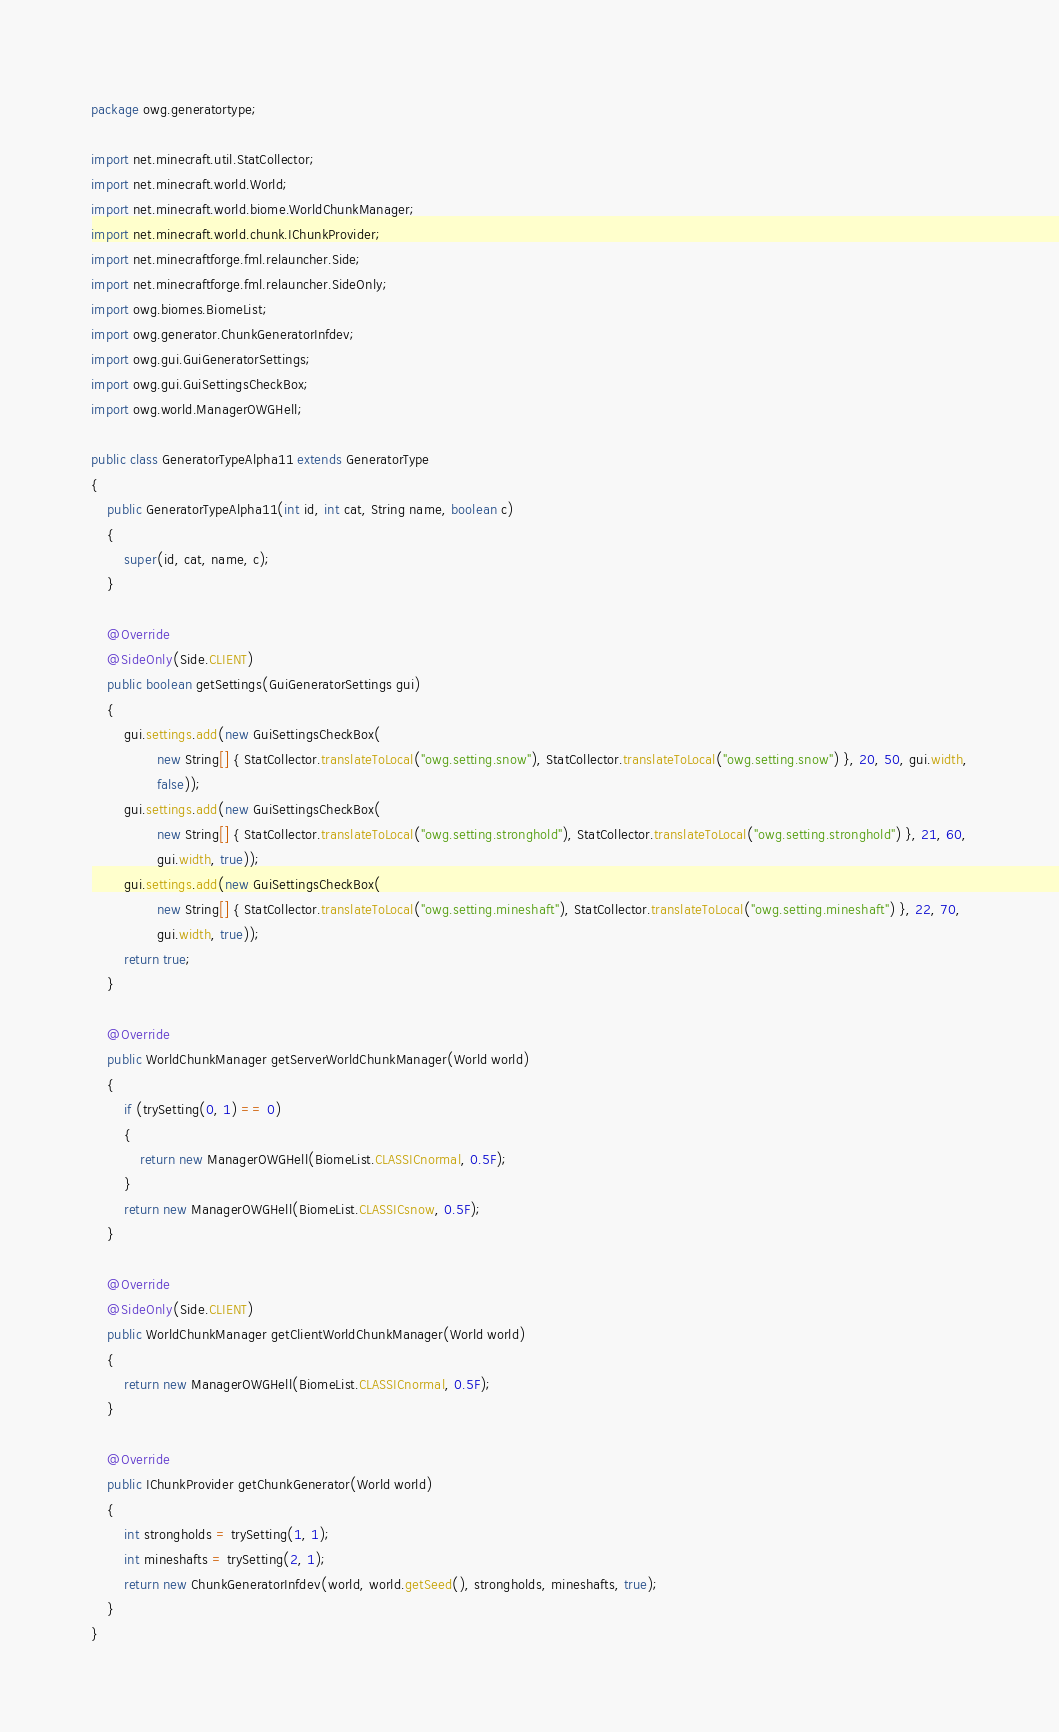Convert code to text. <code><loc_0><loc_0><loc_500><loc_500><_Java_>package owg.generatortype;

import net.minecraft.util.StatCollector;
import net.minecraft.world.World;
import net.minecraft.world.biome.WorldChunkManager;
import net.minecraft.world.chunk.IChunkProvider;
import net.minecraftforge.fml.relauncher.Side;
import net.minecraftforge.fml.relauncher.SideOnly;
import owg.biomes.BiomeList;
import owg.generator.ChunkGeneratorInfdev;
import owg.gui.GuiGeneratorSettings;
import owg.gui.GuiSettingsCheckBox;
import owg.world.ManagerOWGHell;

public class GeneratorTypeAlpha11 extends GeneratorType
{
    public GeneratorTypeAlpha11(int id, int cat, String name, boolean c)
    {
        super(id, cat, name, c);
    }

    @Override
    @SideOnly(Side.CLIENT)
    public boolean getSettings(GuiGeneratorSettings gui)
    {
        gui.settings.add(new GuiSettingsCheckBox(
                new String[] { StatCollector.translateToLocal("owg.setting.snow"), StatCollector.translateToLocal("owg.setting.snow") }, 20, 50, gui.width,
                false));
        gui.settings.add(new GuiSettingsCheckBox(
                new String[] { StatCollector.translateToLocal("owg.setting.stronghold"), StatCollector.translateToLocal("owg.setting.stronghold") }, 21, 60,
                gui.width, true));
        gui.settings.add(new GuiSettingsCheckBox(
                new String[] { StatCollector.translateToLocal("owg.setting.mineshaft"), StatCollector.translateToLocal("owg.setting.mineshaft") }, 22, 70,
                gui.width, true));
        return true;
    }

    @Override
    public WorldChunkManager getServerWorldChunkManager(World world)
    {
        if (trySetting(0, 1) == 0)
        {
            return new ManagerOWGHell(BiomeList.CLASSICnormal, 0.5F);
        }
        return new ManagerOWGHell(BiomeList.CLASSICsnow, 0.5F);
    }

    @Override
    @SideOnly(Side.CLIENT)
    public WorldChunkManager getClientWorldChunkManager(World world)
    {
        return new ManagerOWGHell(BiomeList.CLASSICnormal, 0.5F);
    }

    @Override
    public IChunkProvider getChunkGenerator(World world)
    {
        int strongholds = trySetting(1, 1);
        int mineshafts = trySetting(2, 1);
        return new ChunkGeneratorInfdev(world, world.getSeed(), strongholds, mineshafts, true);
    }
}
</code> 